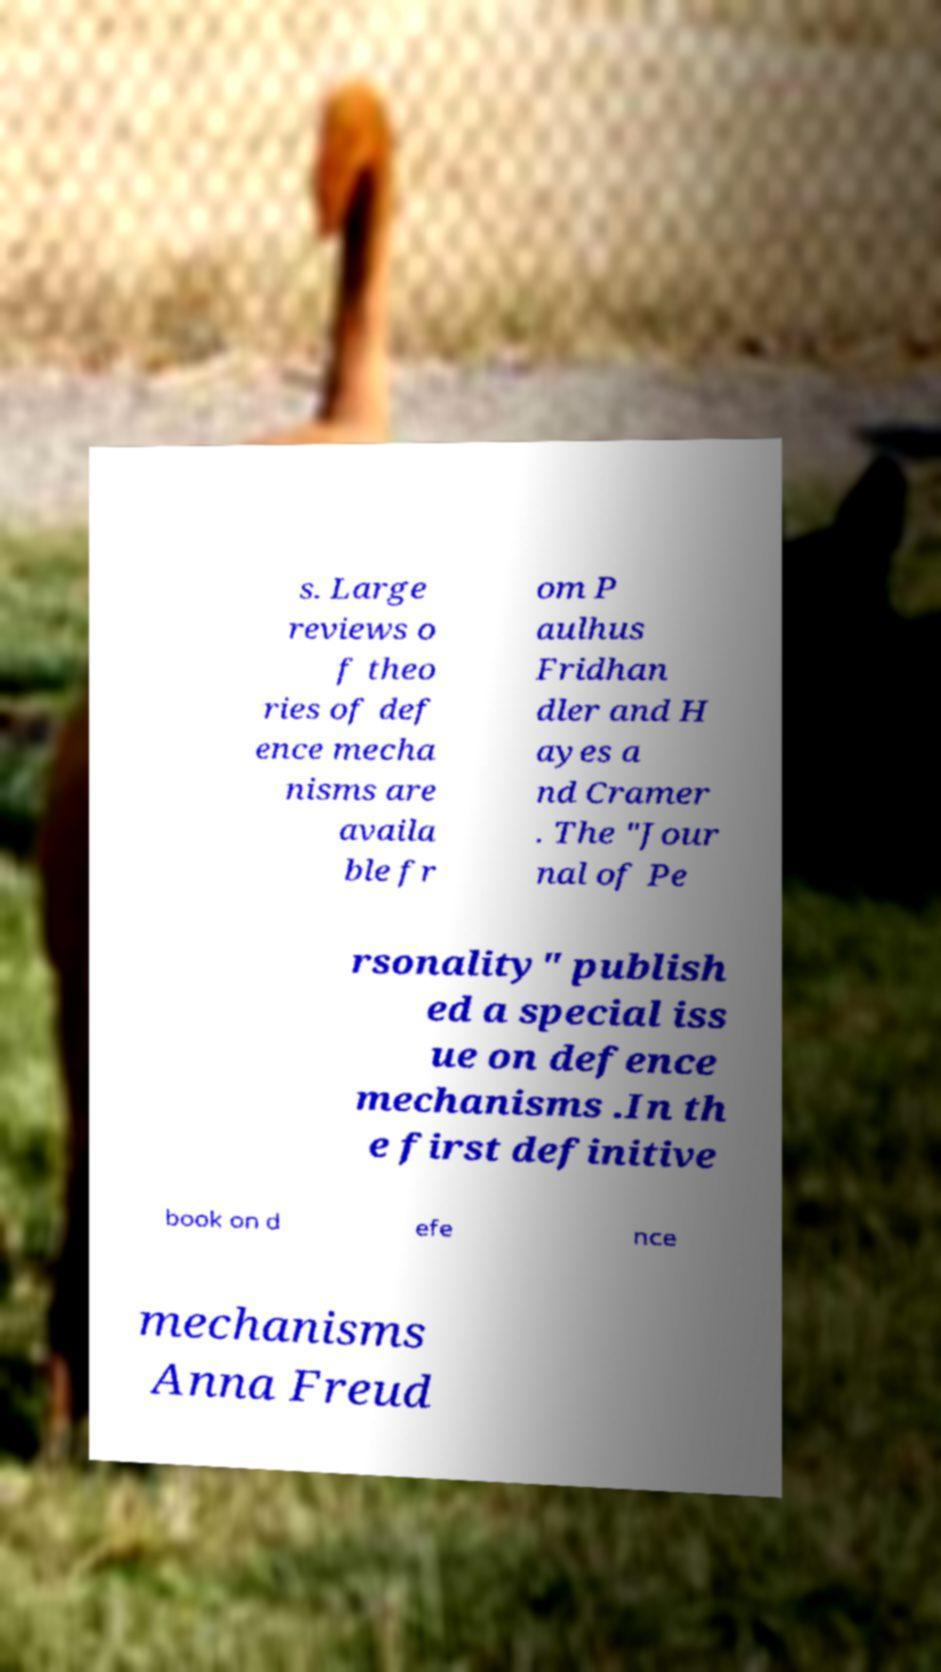Could you assist in decoding the text presented in this image and type it out clearly? s. Large reviews o f theo ries of def ence mecha nisms are availa ble fr om P aulhus Fridhan dler and H ayes a nd Cramer . The "Jour nal of Pe rsonality" publish ed a special iss ue on defence mechanisms .In th e first definitive book on d efe nce mechanisms Anna Freud 